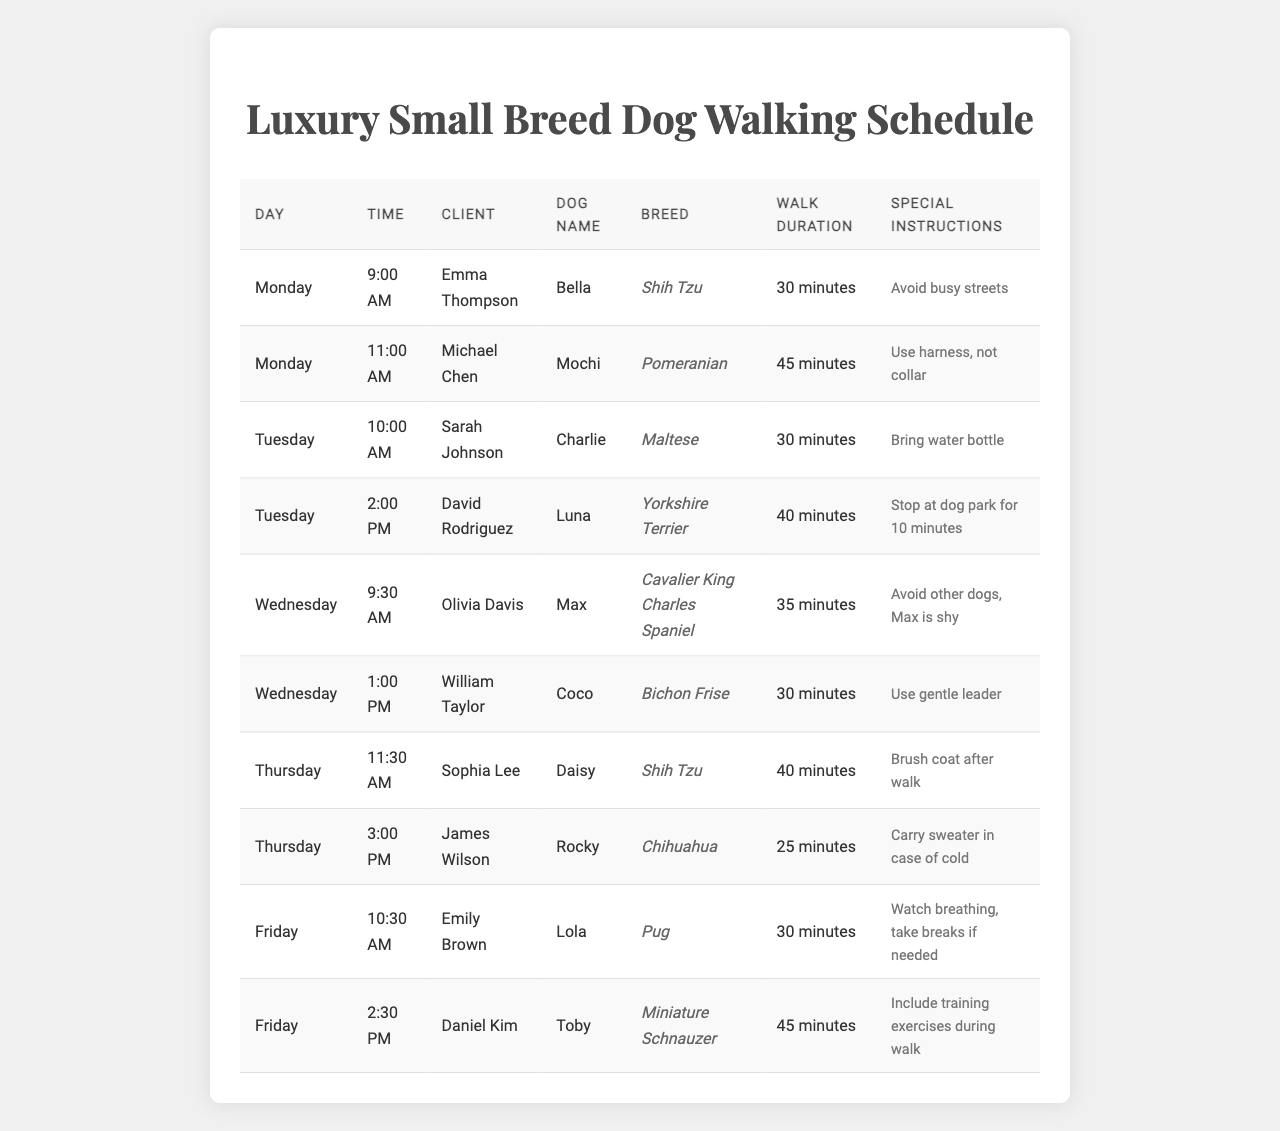What dog breed has the longest walk duration? To find the longest walk duration, I look at the "Walk Duration" column. The durations listed are 30, 45, 30, 40, 35, 30, 40, 25, 30, and 45 minutes. The longest duration is 45 minutes, which corresponds to Mochi (Pomeranian) and Toby (Miniature Schnauzer)
Answer: Pomeranian and Miniature Schnauzer How many clients are scheduled on Friday? Reviewing the table for Friday, there are two distinct clients: Emily Brown and Daniel Kim, who have scheduled walks that day
Answer: 2 Does Bella have any special instructions? To answer this, I check the "Special Instructions" column for Bella, who has instructions stating to avoid busy streets. This confirms that there are indeed special instructions
Answer: Yes On which day is Daisy scheduled for a walk? I look at the "Day" column in the table and find that Daisy is scheduled for a walk on Thursday
Answer: Thursday What is the average walk duration for small breeds? I sum up the walk durations: (30 + 45 + 30 + 40 + 35 + 30 + 40 + 25 + 30 + 45) = 450 minutes. There are 10 entries, so the average is 450/10 = 45 minutes
Answer: 45 minutes Which dog has the shortest walk duration and what is it? Scanning through the "Walk Duration" column, I identify the shortest duration as 25 minutes, which is for Rocky (Chihuahua)
Answer: Rocky (Chihuahua) Were there any clients with similar special instructions? I check the "Special Instructions" column for similarities. Both Michael Chen and Daniel Kim have specific instructions about equipment and behaviors: Michael mentions using a harness, while Daniel mentions including training exercises, which both pertain to how the dogs should be handled. However, they are not exactly the same
Answer: No How many different breeds are represented in the schedule? I examine the "Breed" column, identifying distinct breeds: Shih Tzu, Pomeranian, Maltese, Yorkshire Terrier, Cavalier King Charles Spaniel, Bichon Frise, Chihuahua, and Pug. This makes a total of 8 different breeds in the schedule
Answer: 8 Is there a walk scheduled for a Shih Tzu on Monday? Looking at the table, I see that there is a walk for Bella (Shih Tzu) scheduled on Monday at 9:00 AM
Answer: Yes What time is Max's walk scheduled? Checking the "Time" column for Wednesday, Max's walk is scheduled at 9:30 AM
Answer: 9:30 AM 